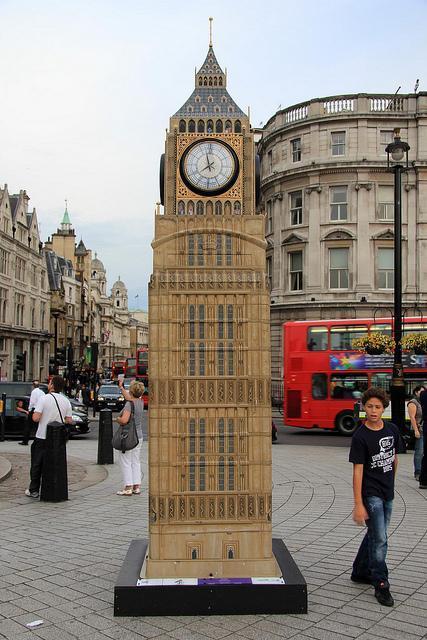How many people are looking at the statue of a clock?
Give a very brief answer. 0. How many people are in the photo?
Give a very brief answer. 2. 